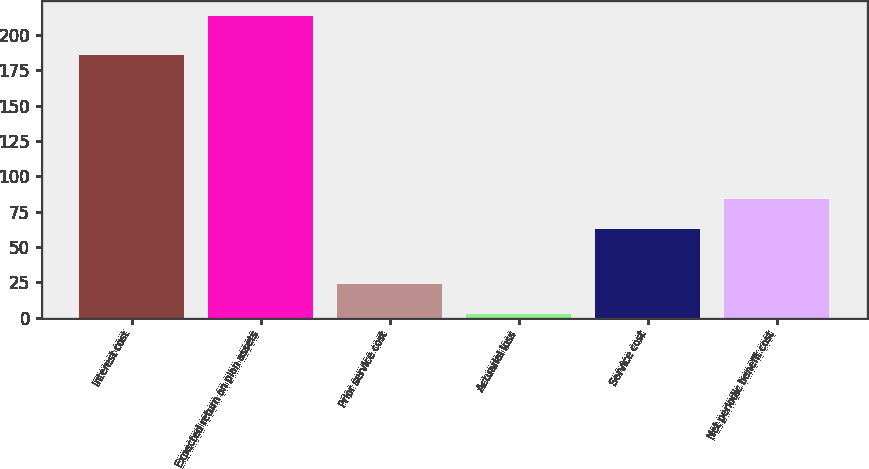Convert chart. <chart><loc_0><loc_0><loc_500><loc_500><bar_chart><fcel>Interest cost<fcel>Expected return on plan assets<fcel>Prior service cost<fcel>Actuarial loss<fcel>Service cost<fcel>Net periodic benefit cost<nl><fcel>186<fcel>213<fcel>24<fcel>3<fcel>63<fcel>84<nl></chart> 